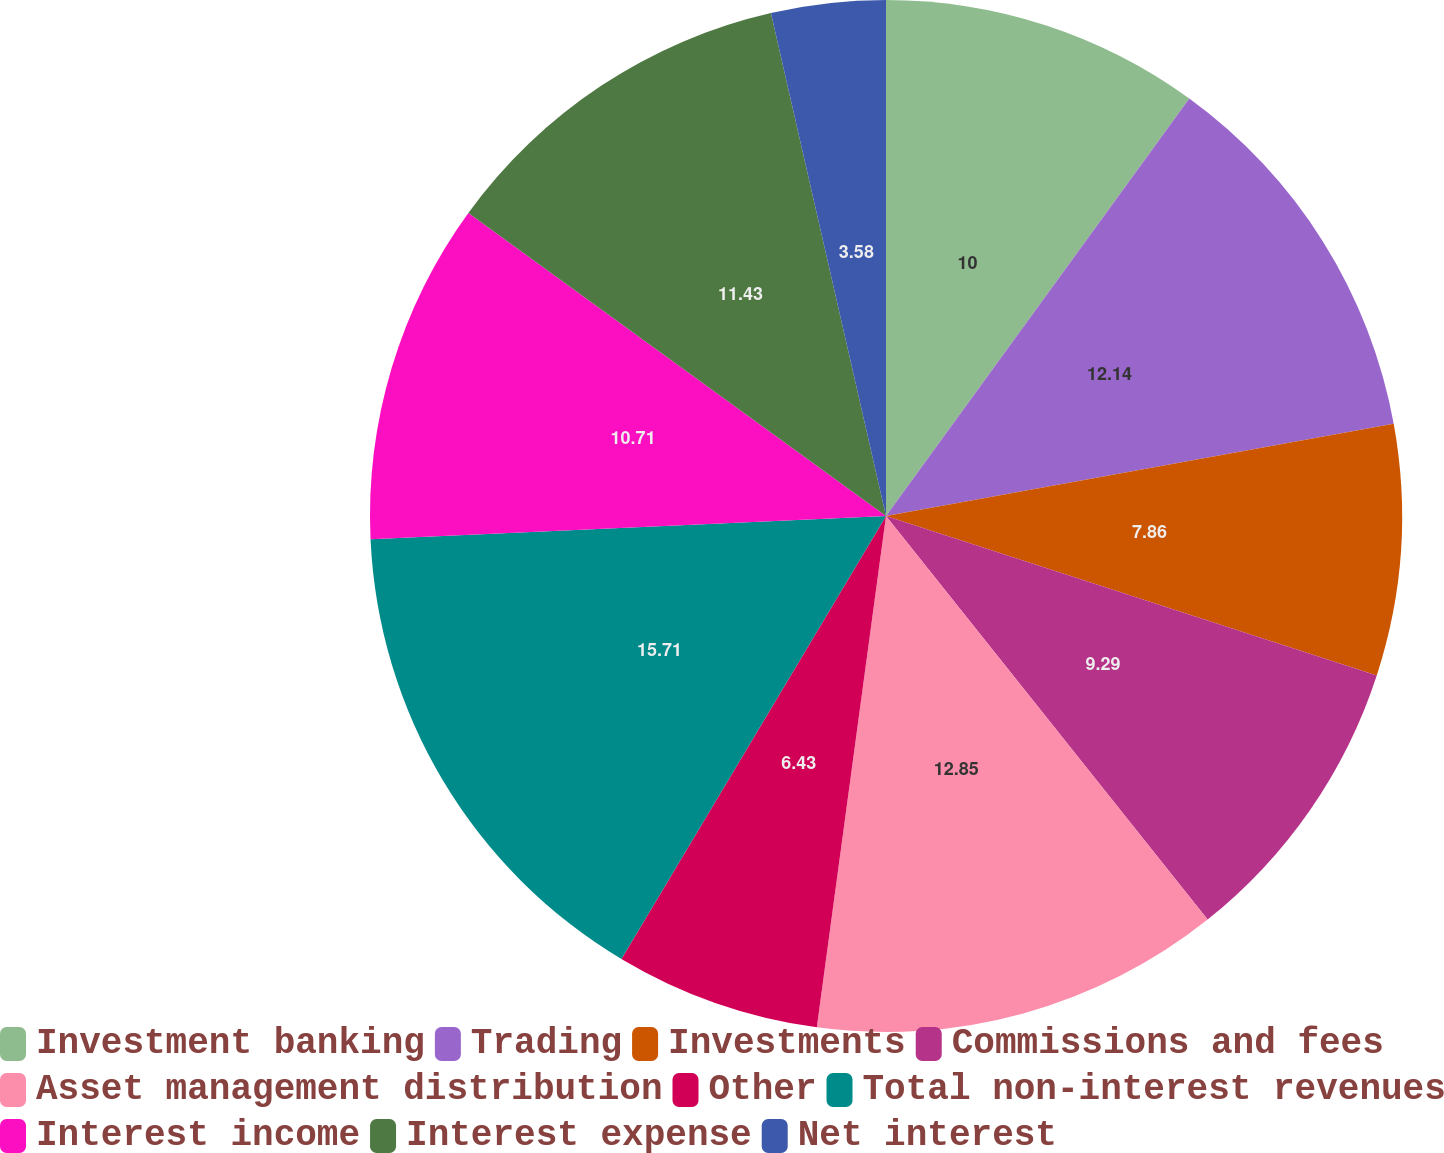<chart> <loc_0><loc_0><loc_500><loc_500><pie_chart><fcel>Investment banking<fcel>Trading<fcel>Investments<fcel>Commissions and fees<fcel>Asset management distribution<fcel>Other<fcel>Total non-interest revenues<fcel>Interest income<fcel>Interest expense<fcel>Net interest<nl><fcel>10.0%<fcel>12.14%<fcel>7.86%<fcel>9.29%<fcel>12.85%<fcel>6.43%<fcel>15.71%<fcel>10.71%<fcel>11.43%<fcel>3.58%<nl></chart> 